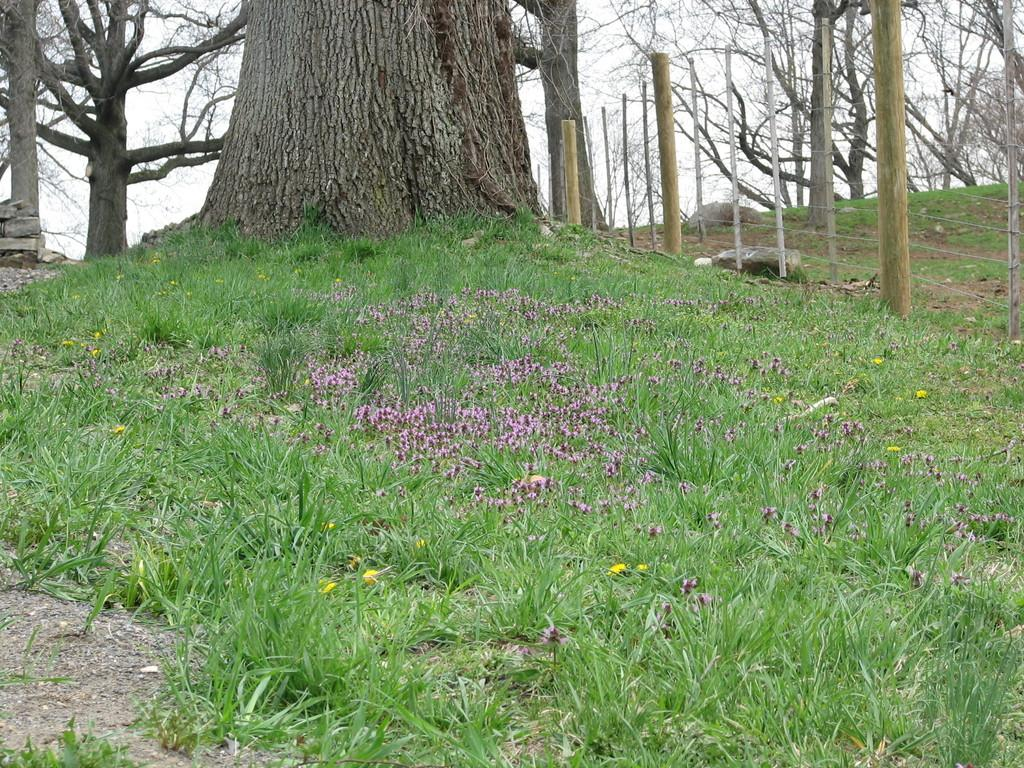What type of plant can be seen in the image? There is a tree in the image. What type of barrier is present in the image? There is fencing in the image. What type of vegetation is visible on the ground in the image? There is grass in the image. What type of flora can be seen in the image? There are flowers in the image. What can be seen in the background of the image? There are trees and the sky visible in the background of the image. How many spiders are crawling on the tree in the image? There are no spiders visible in the image; it only features a tree, fencing, grass, flowers, trees in the background, and the sky. What time of day is it in the image, based on the position of the sun? The position of the sun is not visible in the image, so it is not possible to determine the hour from the image. 